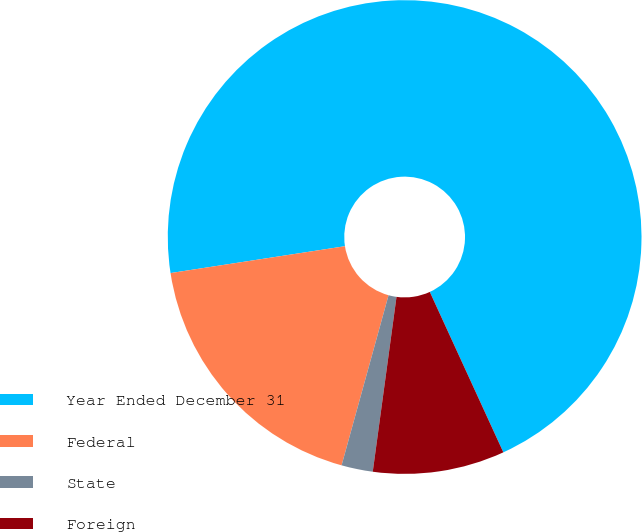<chart> <loc_0><loc_0><loc_500><loc_500><pie_chart><fcel>Year Ended December 31<fcel>Federal<fcel>State<fcel>Foreign<nl><fcel>70.59%<fcel>18.28%<fcel>2.14%<fcel>8.99%<nl></chart> 